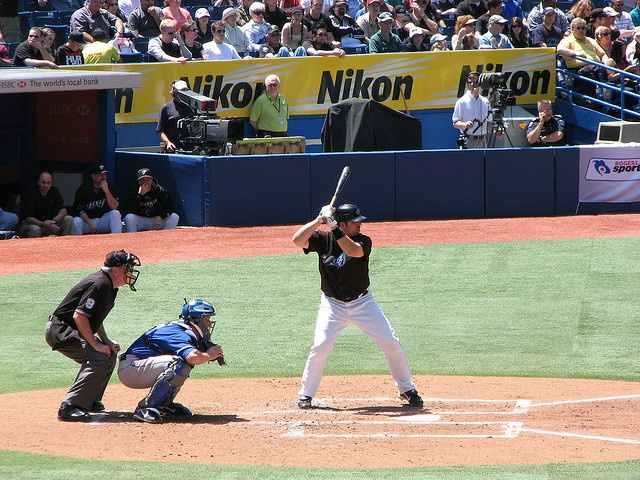Describe the objects in this image and their specific colors. I can see people in black, gray, white, and olive tones, people in black, darkgray, pink, and white tones, people in black, gray, maroon, and darkgray tones, people in black, gray, navy, and white tones, and people in black, gray, maroon, and brown tones in this image. 